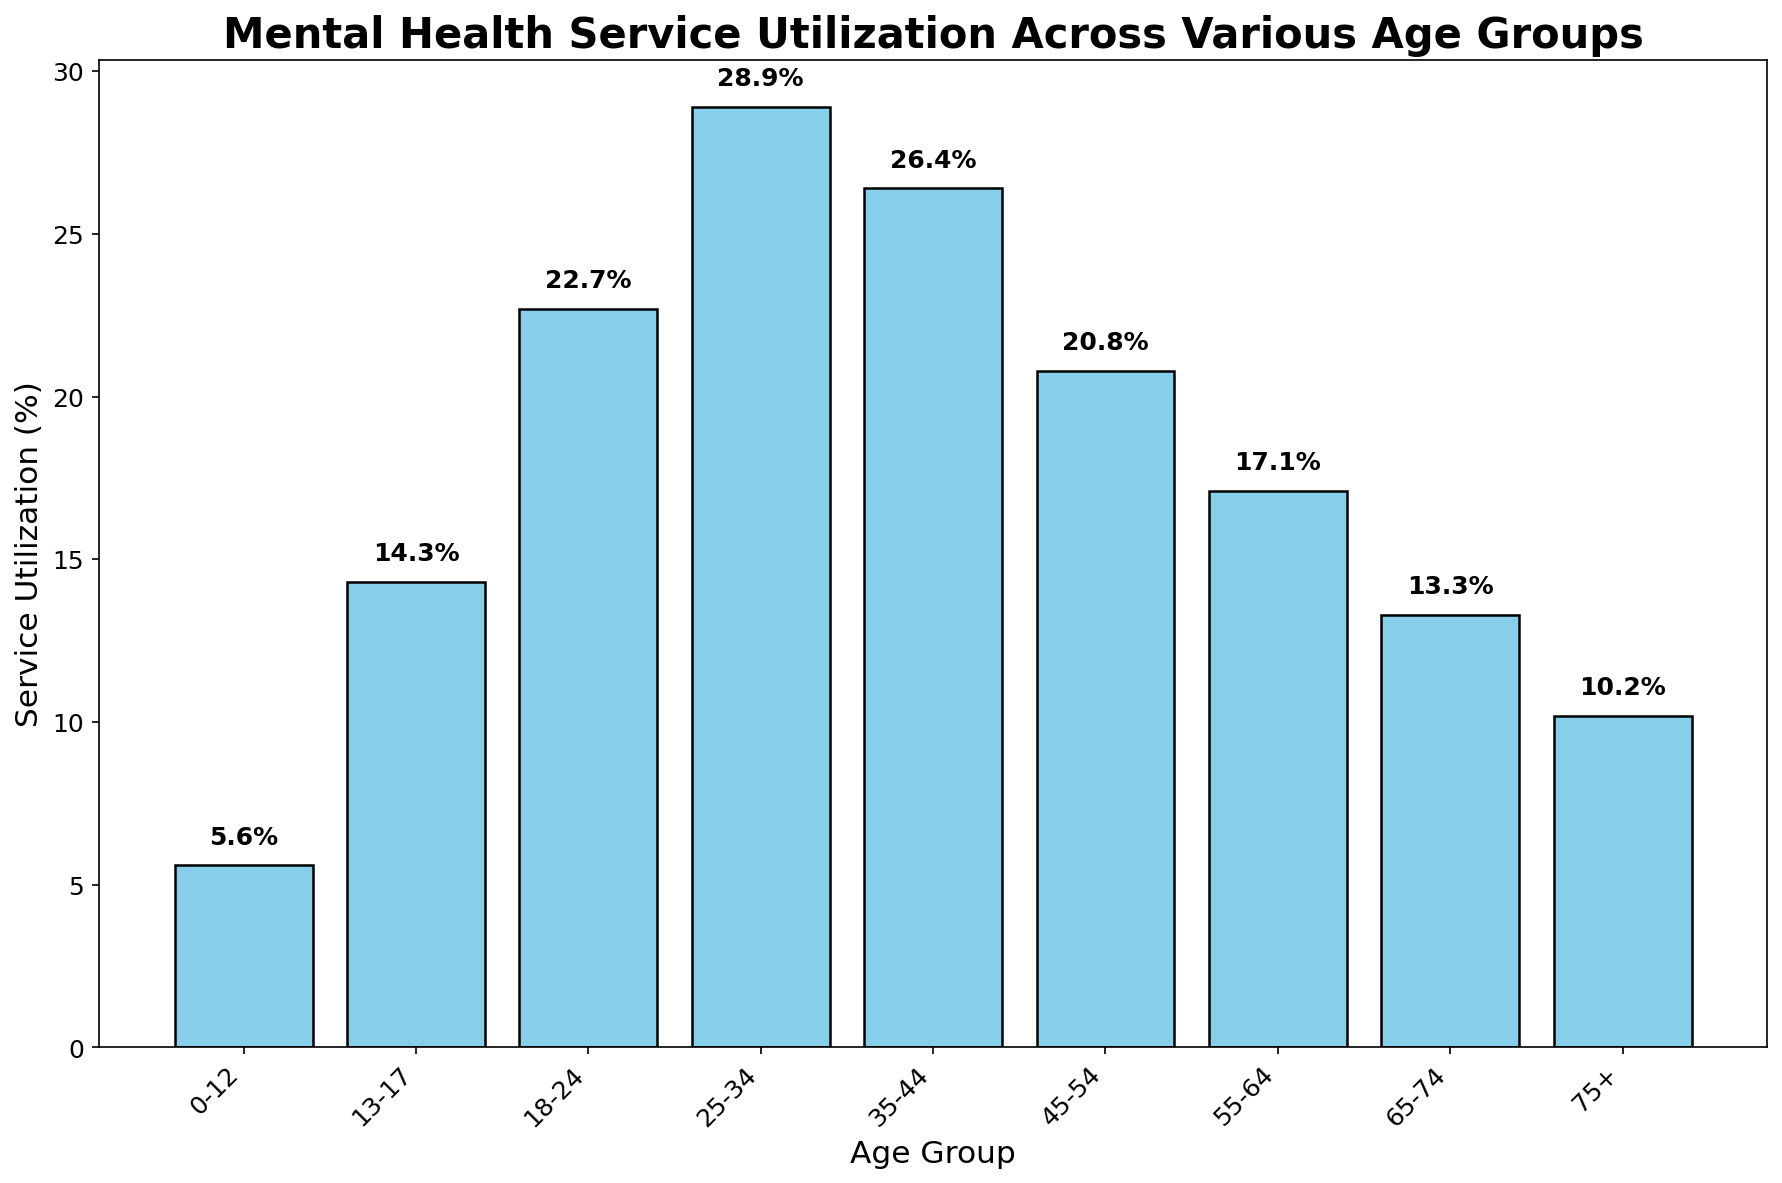What age group has the highest mental health service utilization rate? The bar representing the age group 25-34 is the tallest, indicating that this group has the highest utilization rate.
Answer: 25-34 Which age group shows the lowest mental health service utilization? The bar for the 0-12 age group is the shortest, indicating the lowest utilization rate.
Answer: 0-12 What is the difference in service utilization between the 18-24 and 45-54 age groups? The utilization for the 18-24 age group is 22.7%, and for the 45-54 age group, it is 20.8%. Subtracting 20.8 from 22.7 gives the difference.
Answer: 1.9% How much higher is the service utilization rate for the 25-34 age group compared to the 65-74 age group? The 25-34 age group has a rate of 28.9%, and the 65-74 age group has a rate of 13.3%. Subtracting 13.3 from 28.9 gives the difference.
Answer: 15.6% What is the average mental health service utilization rate for the age groups 55-64, 65-74, and 75+? Adding up the utilization rates for these groups (17.1 + 13.3 + 10.2) and dividing by the number of groups (3) gives the average. (17.1 + 13.3 + 10.2) / 3 = 40.6 / 3 = 13.53
Answer: 13.5% Do the age groups 25-34 and 35-44 have similar mental health service utilization rates? The utilization rate for 25-34 is 28.9%, and for 35-44, it is 26.4%. The rates are close but not identical.
Answer: No Which age group has more than double the service utilization rate of the 75+ age group? The 75+ group has a utilization rate of 10.2%. Doubling that gives 20.4%. The age group 25-34 with 28.9% has more than double this rate.
Answer: 25-34 What is the sum of mental health service utilization rates for the age groups 13-17, 18-24, and 25-34? The utilization rates are 14.3% for 13-17, 22.7% for 18-24, and 28.9% for 25-34. Adding these gives the total: 14.3 + 22.7 + 28.9 = 65.9
Answer: 65.9% How many age groups have a service utilization rate lower than 15%? Counting the groups with utilization rates lower than 15% (0-12 is 5.6%, 13-17 is 14.3%, 65-74 is 13.3%, 75+ is 10.2%) gives four groups.
Answer: 4 Does the mental health service utilization rate decrease consistently after the age group 25-34? After the 25-34 age group, the utilization rates are 26.4% (35-44), 20.8% (45-54), 17.1% (55-64), 13.3% (65-74), and 10.2% (75+). This shows a decreasing trend overall but not a strict pattern.
Answer: Yes 